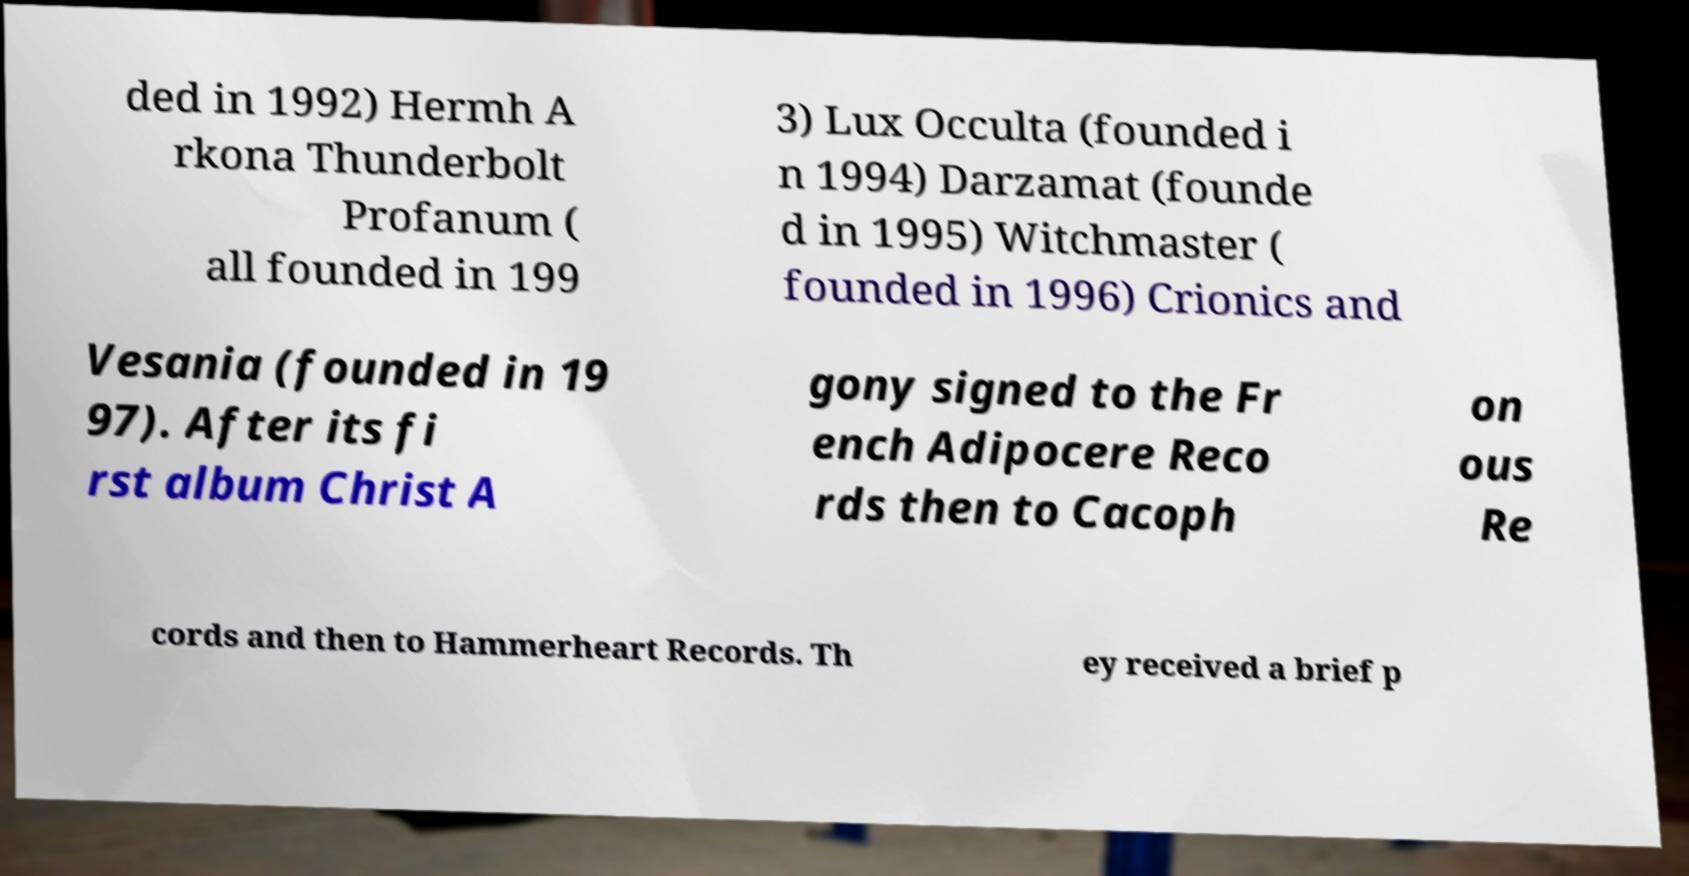There's text embedded in this image that I need extracted. Can you transcribe it verbatim? ded in 1992) Hermh A rkona Thunderbolt Profanum ( all founded in 199 3) Lux Occulta (founded i n 1994) Darzamat (founde d in 1995) Witchmaster ( founded in 1996) Crionics and Vesania (founded in 19 97). After its fi rst album Christ A gony signed to the Fr ench Adipocere Reco rds then to Cacoph on ous Re cords and then to Hammerheart Records. Th ey received a brief p 